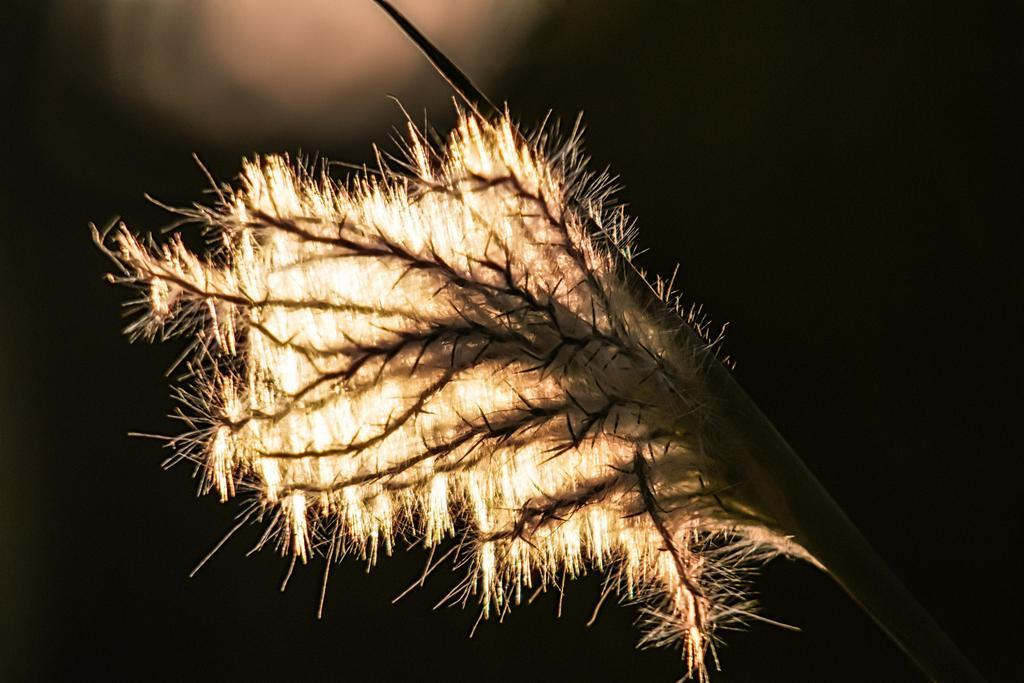What is the main subject of the image? The main subject of the image is a flower. What specific feature does the flower have? The flower has thorns. Can you describe the part of the flower that connects it to the plant? The stem of the flower is visible. What can be observed about the overall lighting or color scheme of the image? The background of the image is dark. What type of poison can be seen dripping from the flower in the image? There is no poison present in the image; it is a flower with thorns. Can you tell me how many stars are visible in the background of the image? There are no stars visible in the image, as the background is dark. 